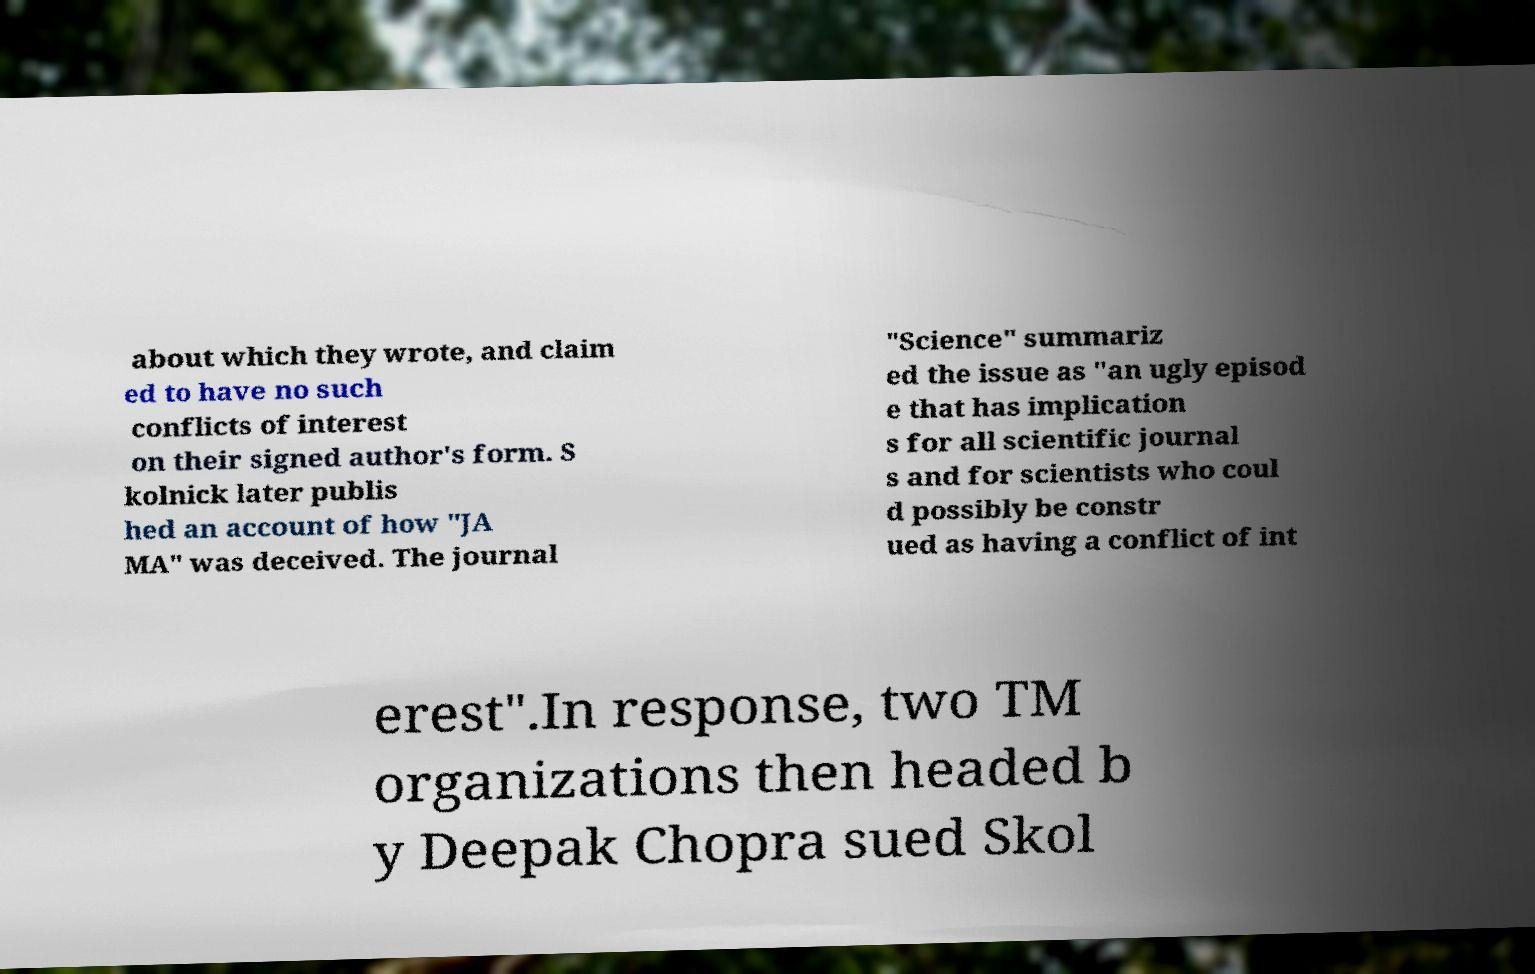I need the written content from this picture converted into text. Can you do that? about which they wrote, and claim ed to have no such conflicts of interest on their signed author's form. S kolnick later publis hed an account of how "JA MA" was deceived. The journal "Science" summariz ed the issue as "an ugly episod e that has implication s for all scientific journal s and for scientists who coul d possibly be constr ued as having a conflict of int erest".In response, two TM organizations then headed b y Deepak Chopra sued Skol 